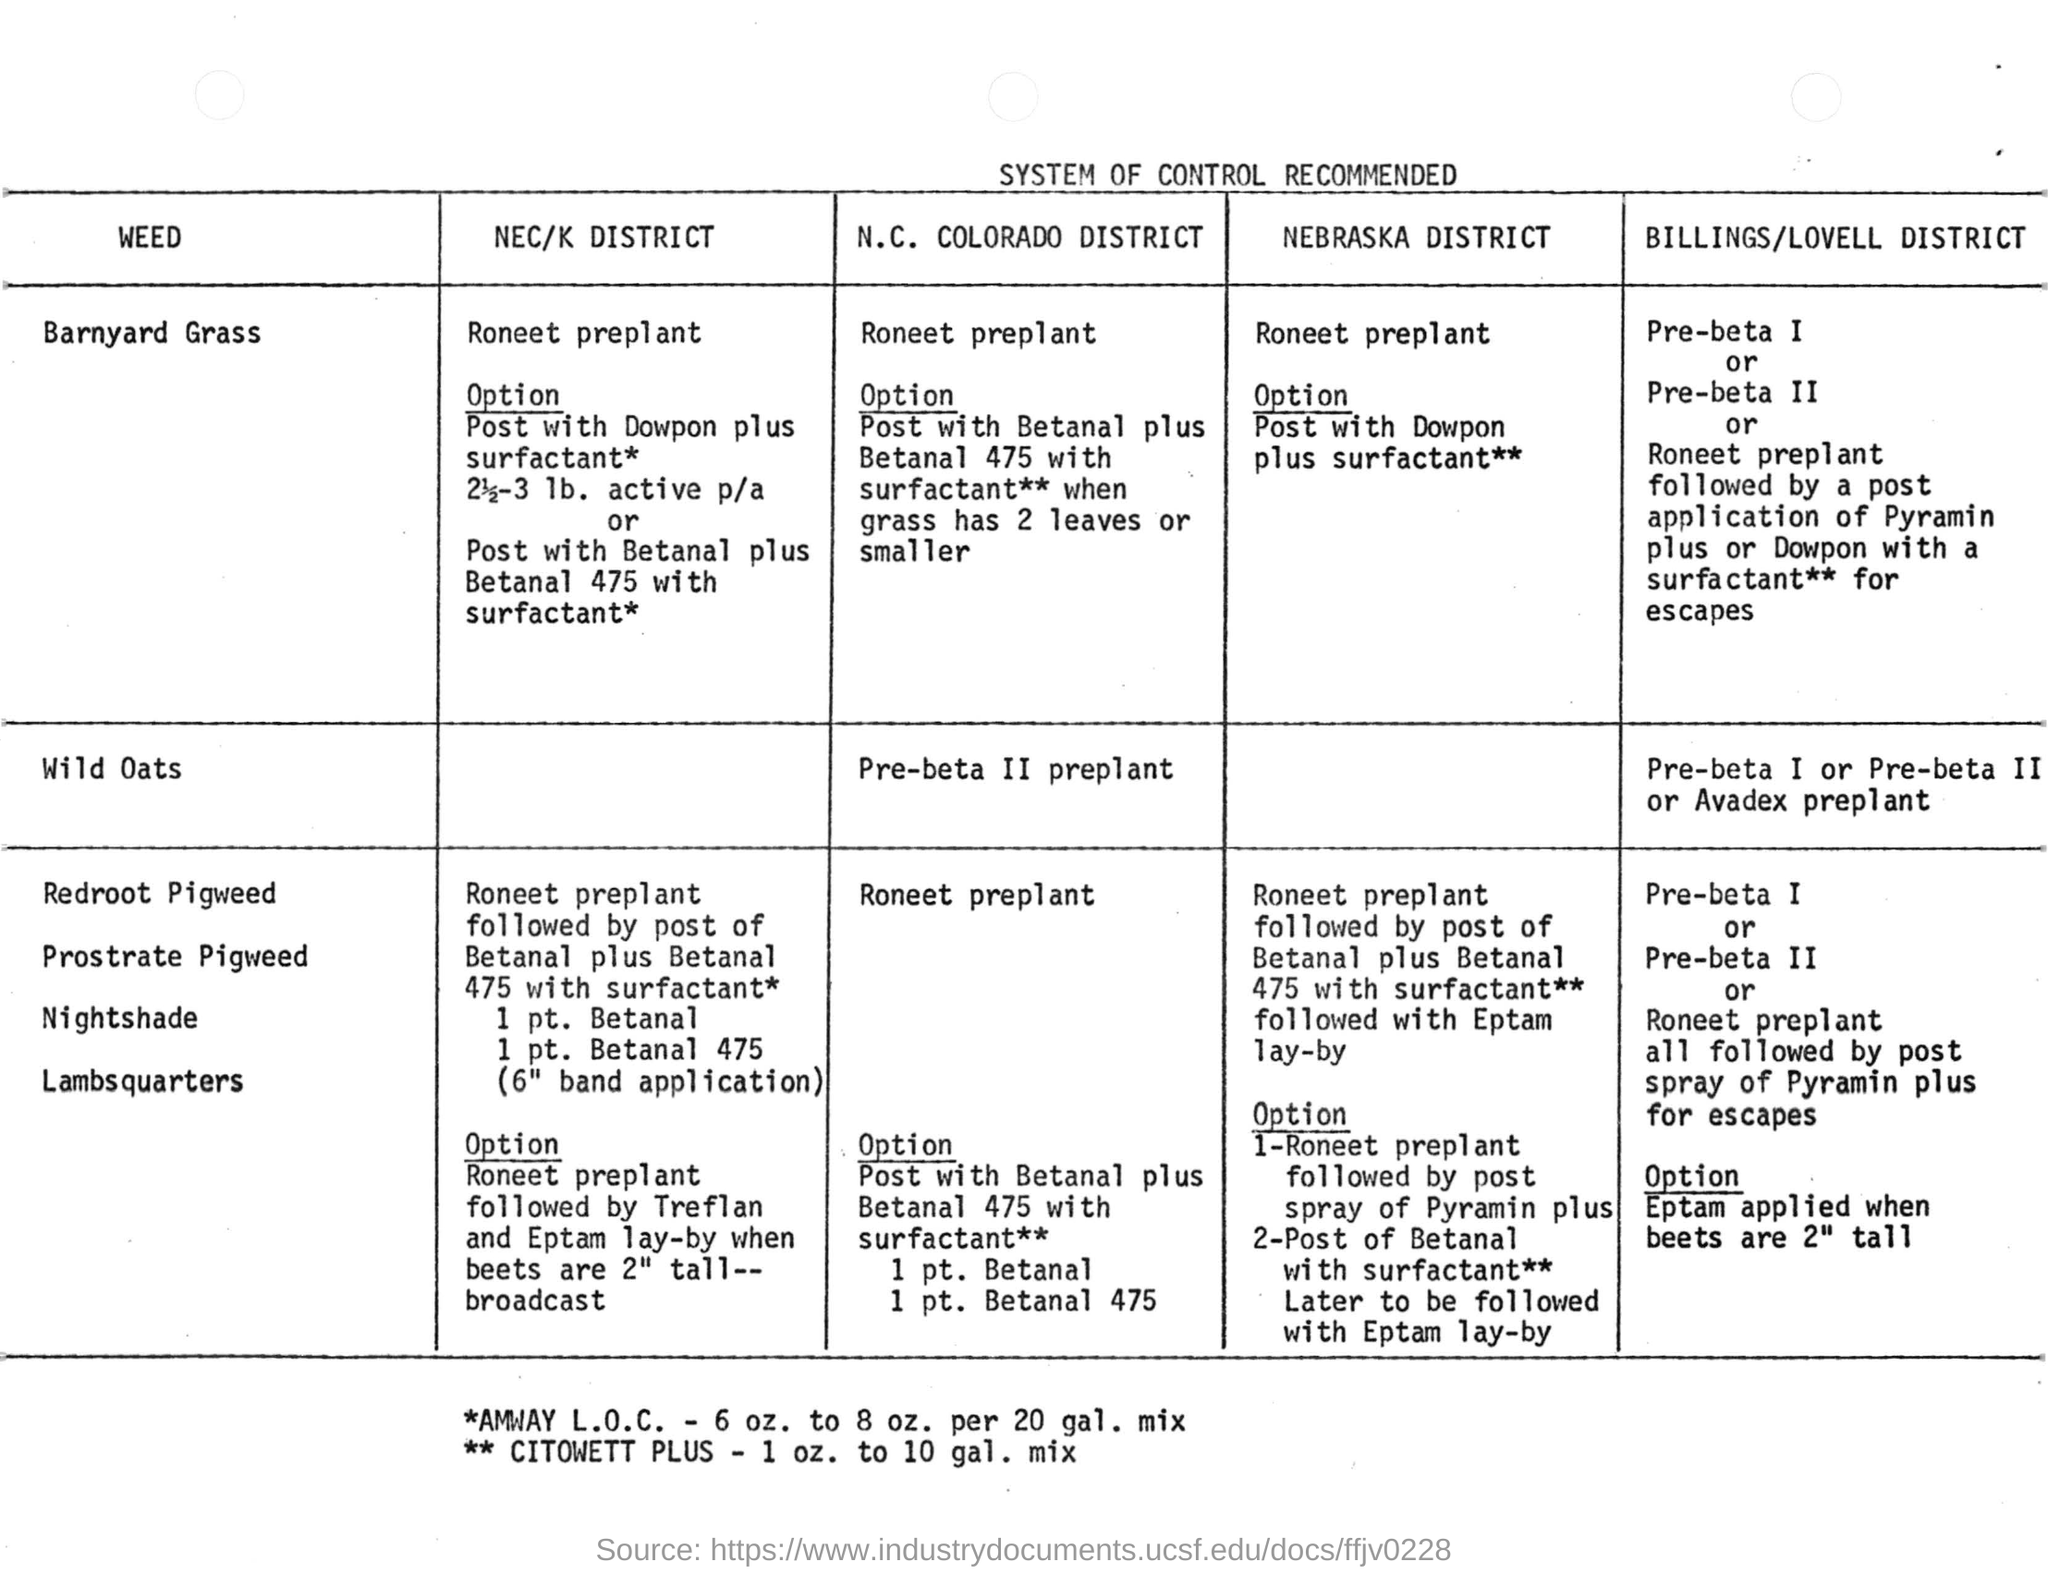What is the heading for the document?
Your response must be concise. System of control recommended. What is the option for the barnyard grass weed at n.c. colorado district ?
Your response must be concise. Post with Betanal plus Betanal 475 with surfactant ** when grass has 2 leaves or smaller. 